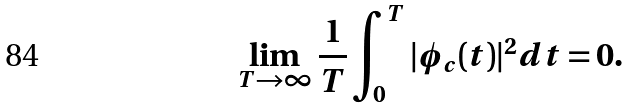<formula> <loc_0><loc_0><loc_500><loc_500>\lim _ { T \to \infty } \frac { 1 } { T } \int _ { 0 } ^ { T } | \phi _ { c } ( t ) | ^ { 2 } d t = 0 .</formula> 